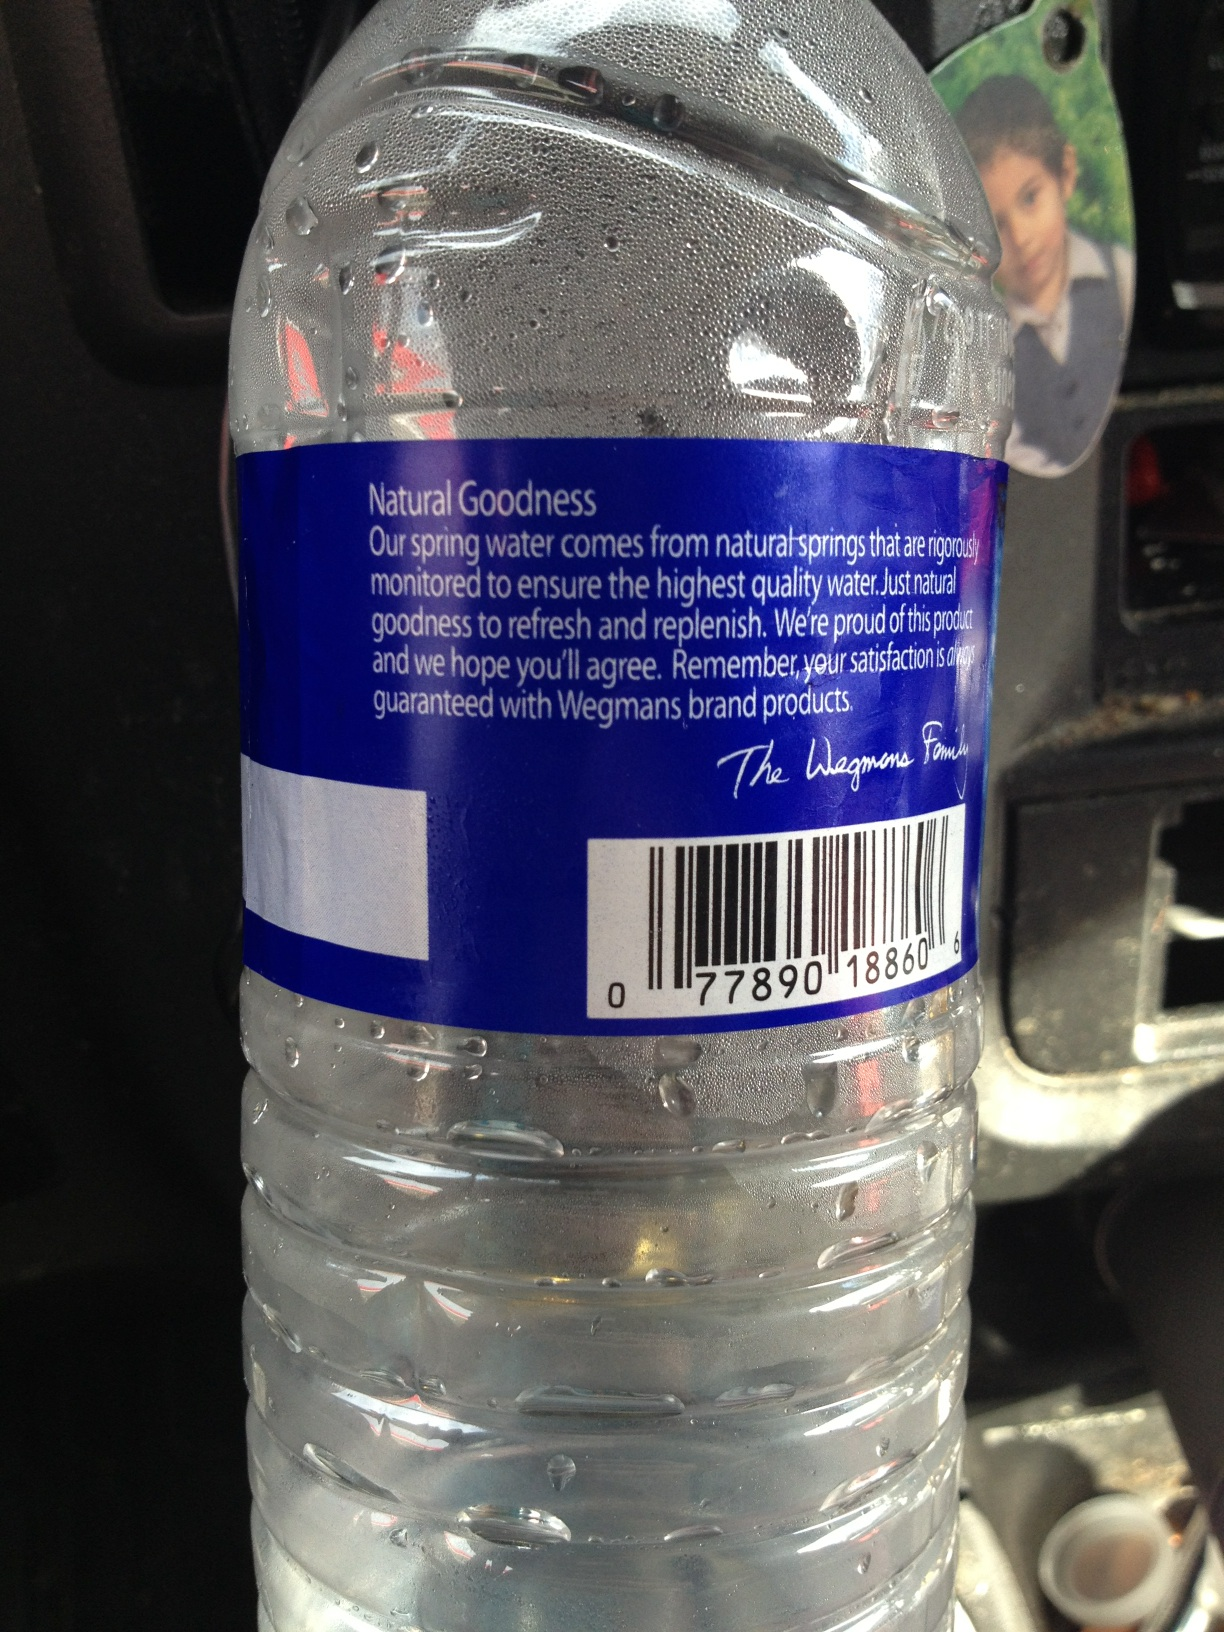What interesting facts can you tell me about the natural springs water is sourced from? Natural springs, like the ones Wegmans sources its water from, are often located in pristine environments, far from industrial pollution. The water is naturally filtered through layers of rock, which adds minerals and enhances its taste. This rigorous natural filtration process helps maintain the water’s purity and health benefits, contributing to the refreshing taste that sets spring water apart. 